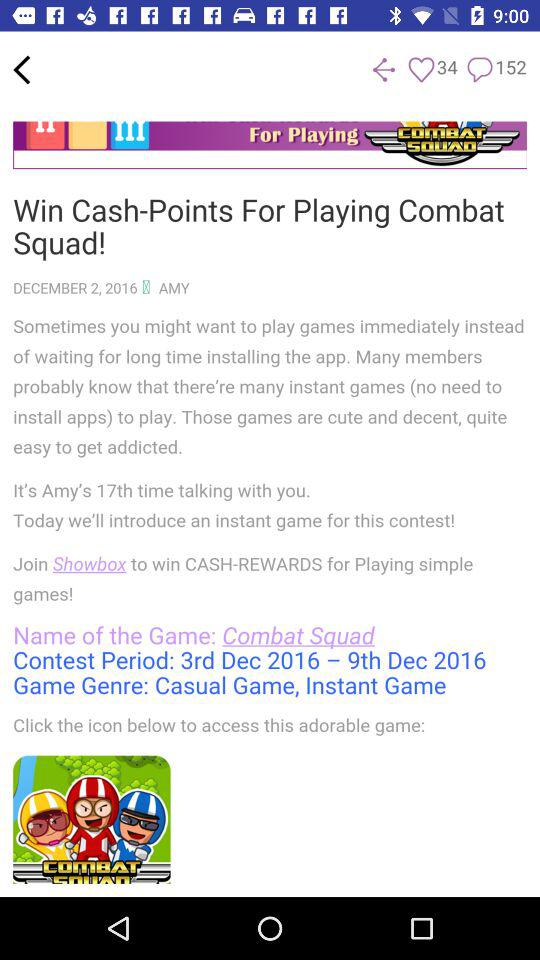How many comments are there on the screen? There are 152 comments. 